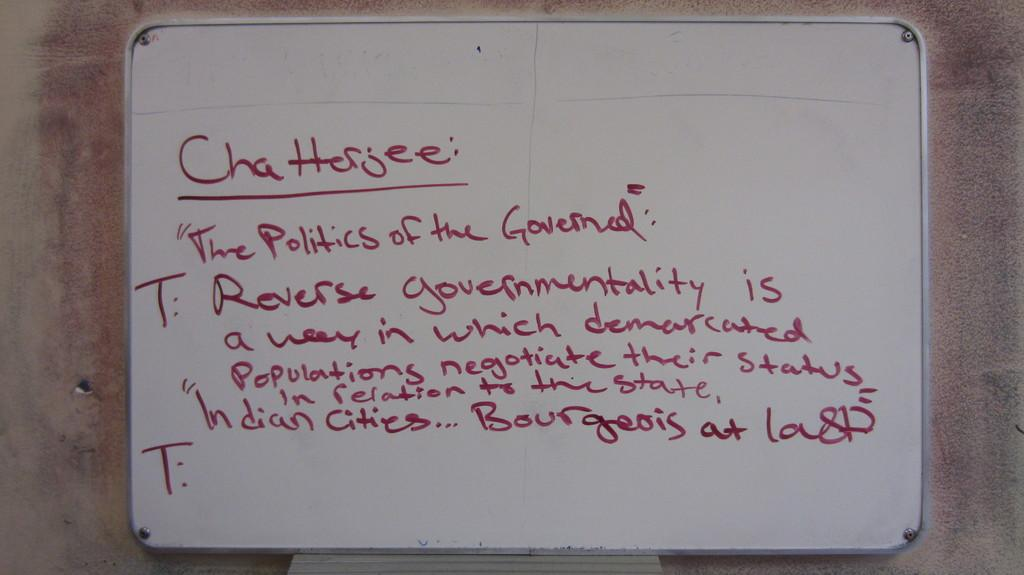<image>
Present a compact description of the photo's key features. A whiteboard with red writing for the politics of the governed. 